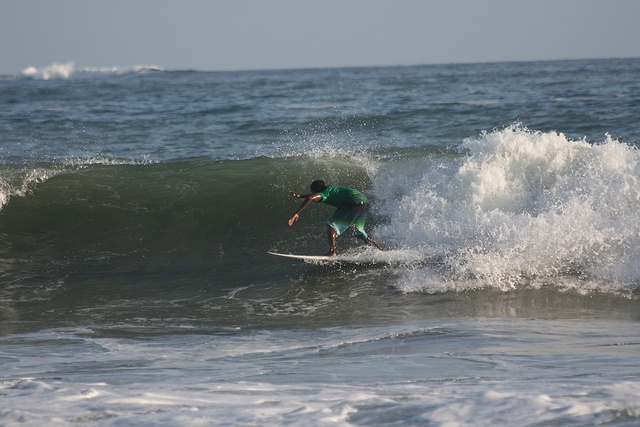Describe the objects in this image and their specific colors. I can see people in gray, black, teal, and maroon tones and surfboard in gray, darkgray, and black tones in this image. 